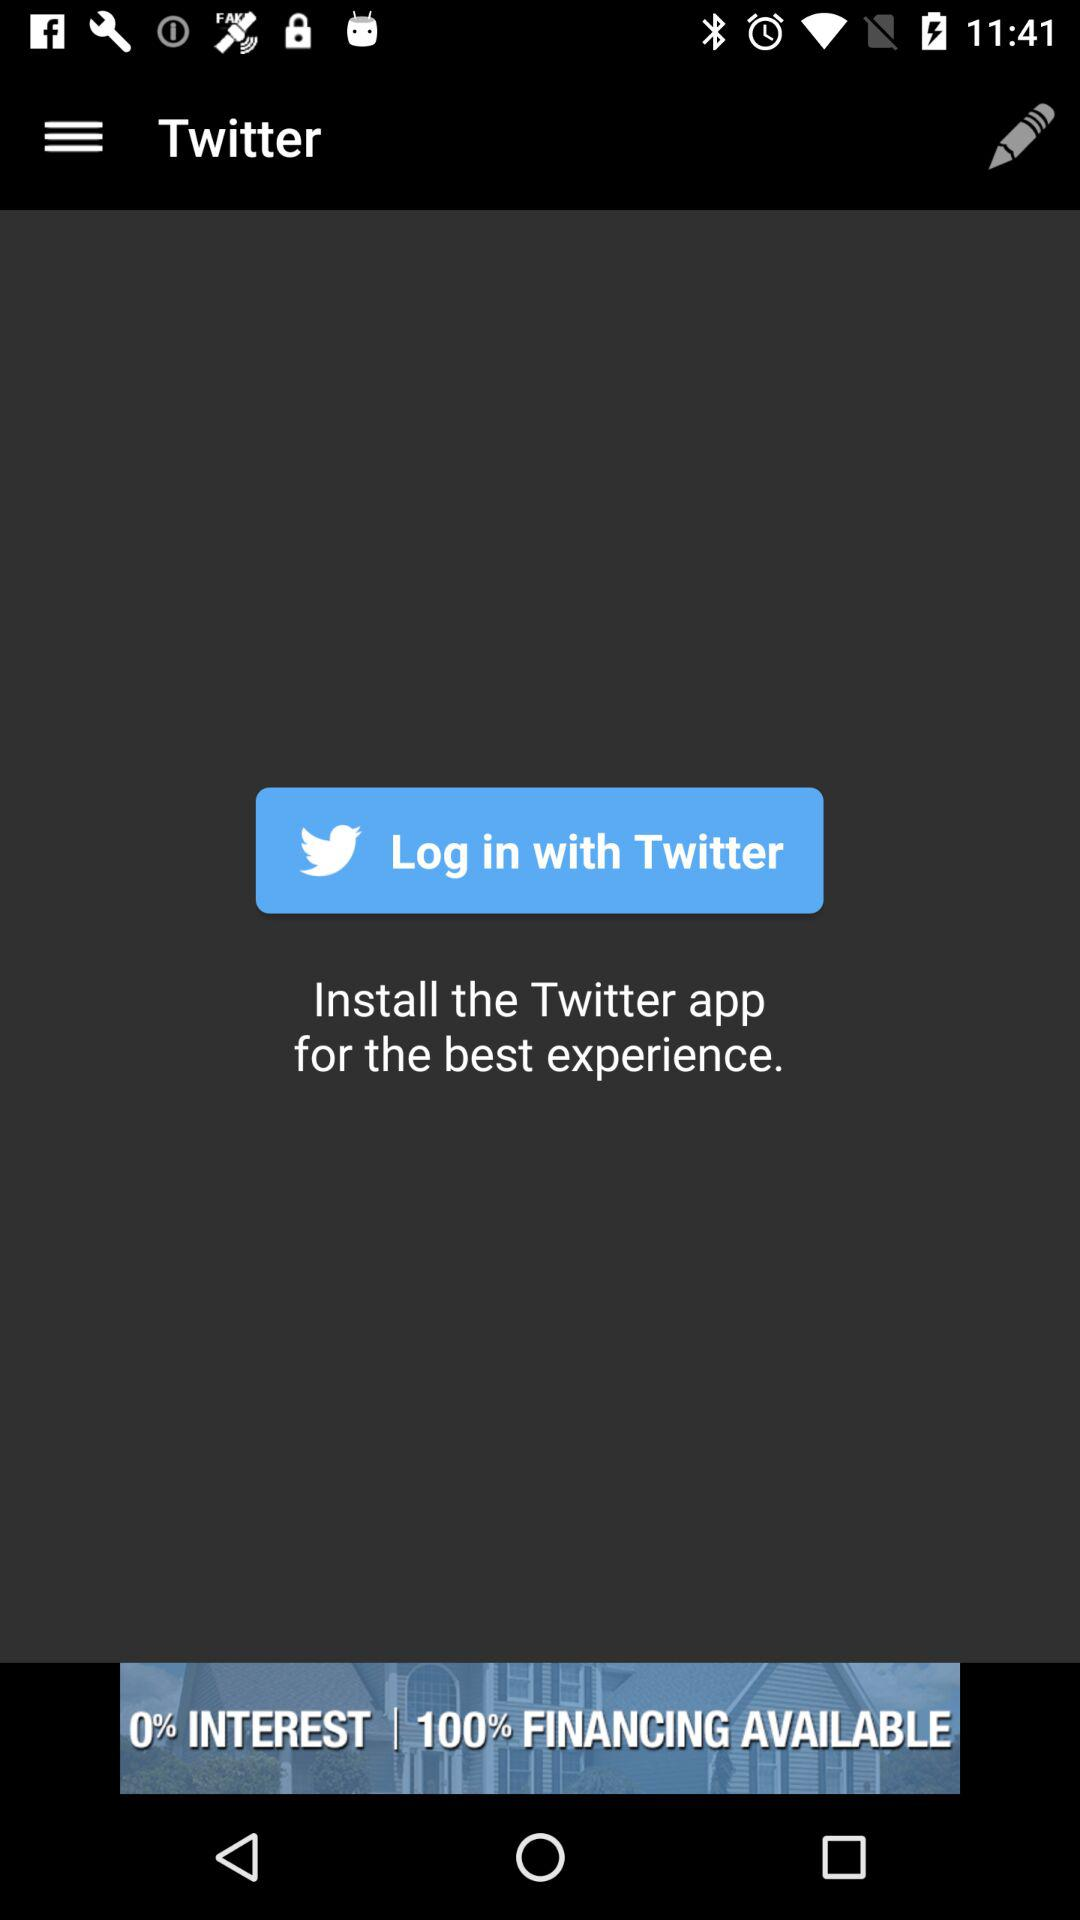What is the Twitter username?
When the provided information is insufficient, respond with <no answer>. <no answer> 